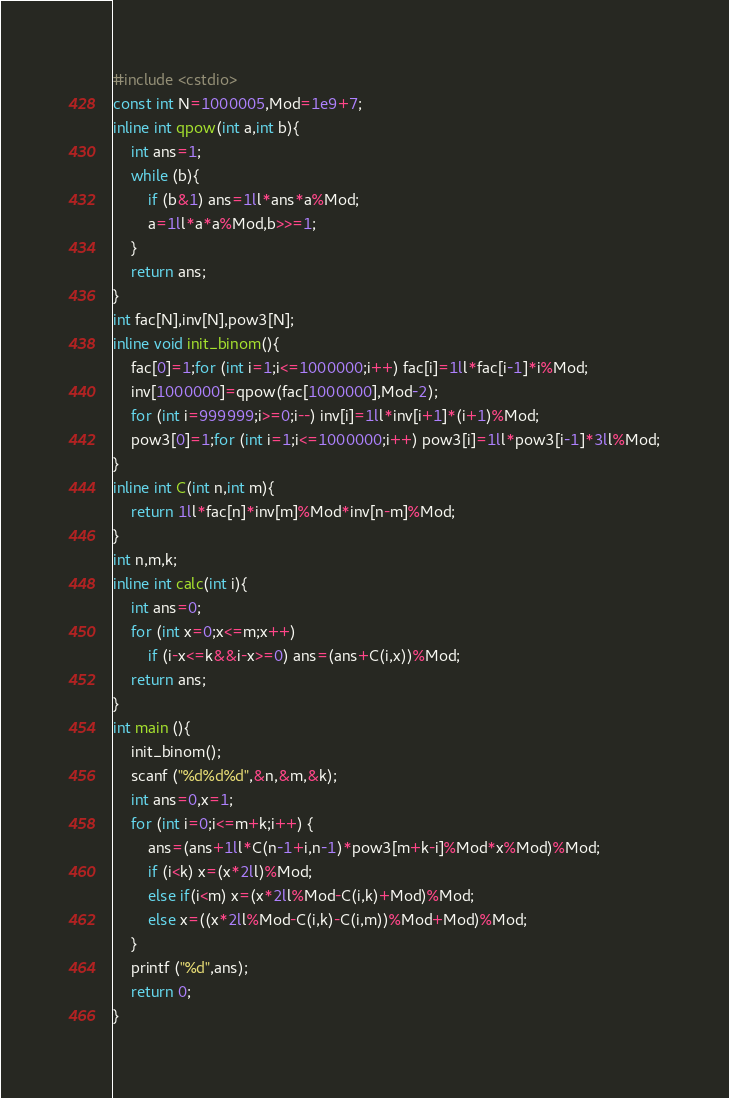Convert code to text. <code><loc_0><loc_0><loc_500><loc_500><_C++_>#include <cstdio>
const int N=1000005,Mod=1e9+7;
inline int qpow(int a,int b){
	int ans=1;
	while (b){
		if (b&1) ans=1ll*ans*a%Mod;
		a=1ll*a*a%Mod,b>>=1; 
	}
	return ans;
}
int fac[N],inv[N],pow3[N];
inline void init_binom(){
	fac[0]=1;for (int i=1;i<=1000000;i++) fac[i]=1ll*fac[i-1]*i%Mod;
	inv[1000000]=qpow(fac[1000000],Mod-2);
	for (int i=999999;i>=0;i--) inv[i]=1ll*inv[i+1]*(i+1)%Mod;
	pow3[0]=1;for (int i=1;i<=1000000;i++) pow3[i]=1ll*pow3[i-1]*3ll%Mod;
}
inline int C(int n,int m){
	return 1ll*fac[n]*inv[m]%Mod*inv[n-m]%Mod;
}
int n,m,k;
inline int calc(int i){
	int ans=0;
	for (int x=0;x<=m;x++)
		if (i-x<=k&&i-x>=0) ans=(ans+C(i,x))%Mod;
	return ans;
}
int main (){
	init_binom();
	scanf ("%d%d%d",&n,&m,&k);
	int ans=0,x=1;
	for (int i=0;i<=m+k;i++) {
        ans=(ans+1ll*C(n-1+i,n-1)*pow3[m+k-i]%Mod*x%Mod)%Mod;
        if (i<k) x=(x*2ll)%Mod;
        else if(i<m) x=(x*2ll%Mod-C(i,k)+Mod)%Mod;
        else x=((x*2ll%Mod-C(i,k)-C(i,m))%Mod+Mod)%Mod;
    }
	printf ("%d",ans);
	return 0;
}
</code> 